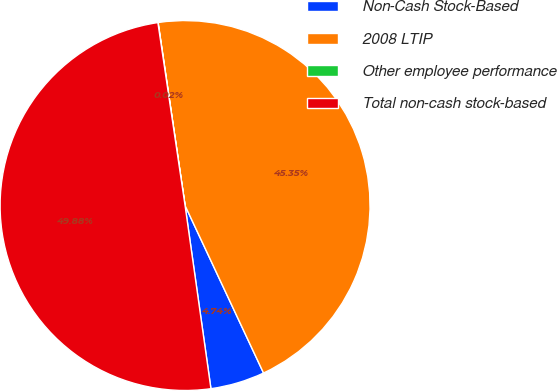<chart> <loc_0><loc_0><loc_500><loc_500><pie_chart><fcel>Non-Cash Stock-Based<fcel>2008 LTIP<fcel>Other employee performance<fcel>Total non-cash stock-based<nl><fcel>4.74%<fcel>45.35%<fcel>0.02%<fcel>49.88%<nl></chart> 